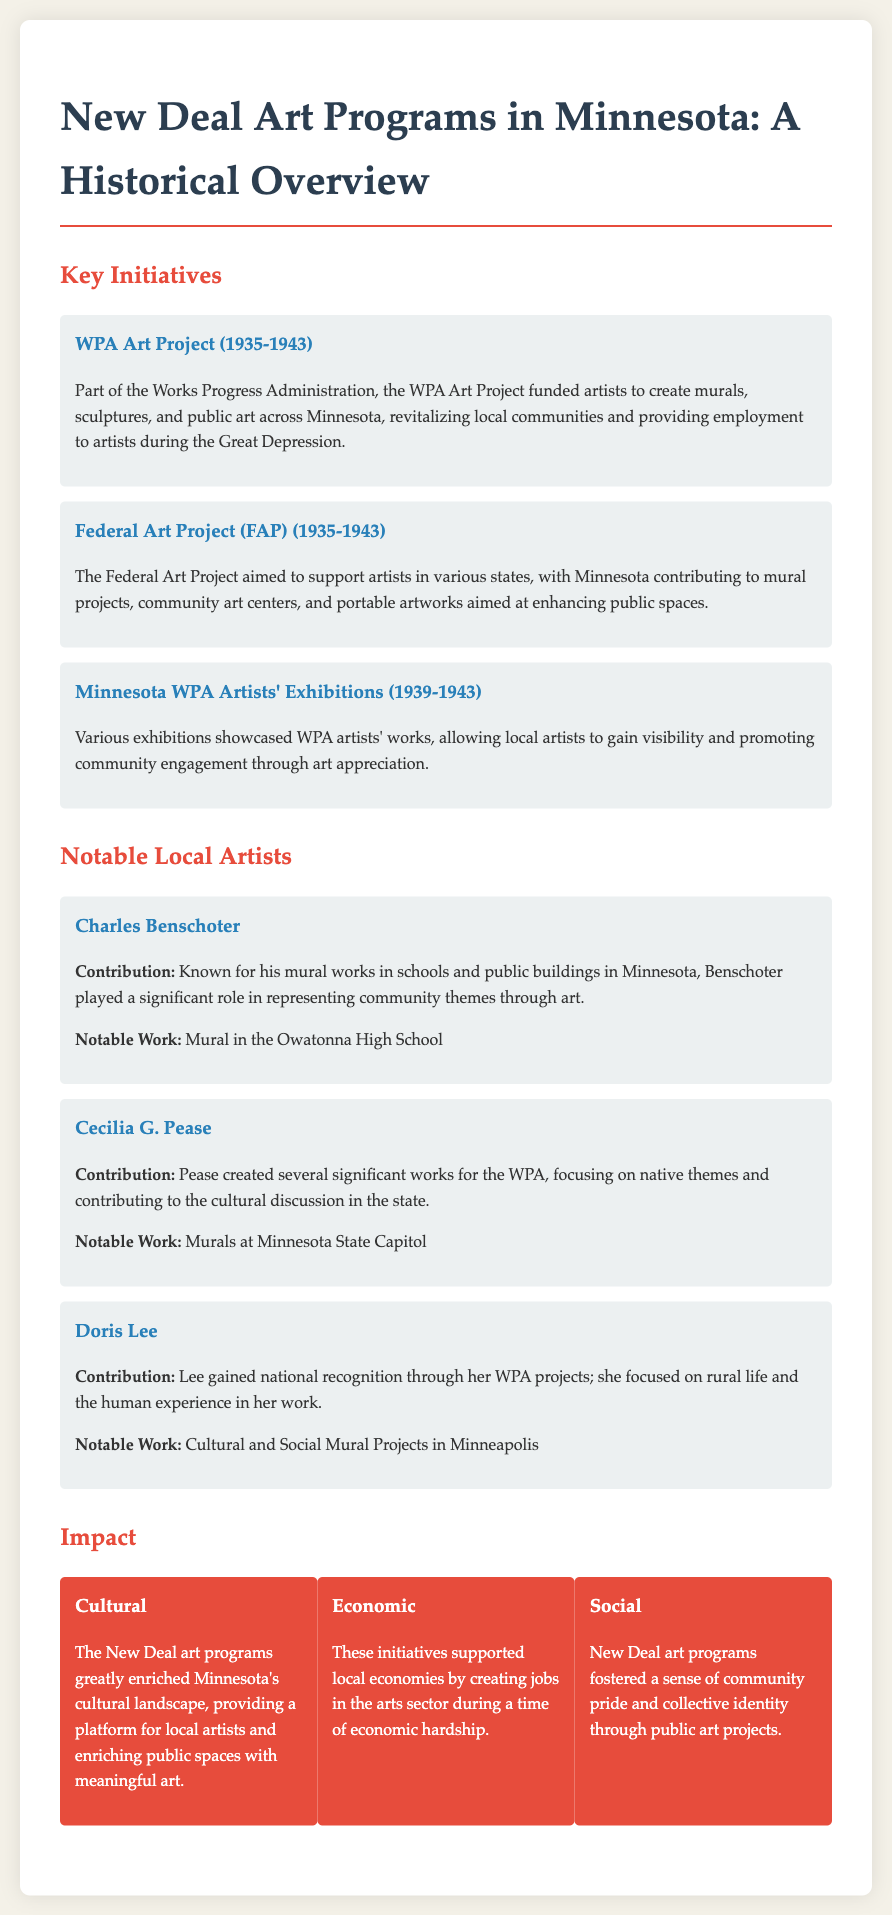What was the period of the WPA Art Project? The WPA Art Project operated from 1935 to 1943.
Answer: 1935-1943 What was one of the aims of the Federal Art Project? The Federal Art Project aimed to support artists and enhance public spaces.
Answer: Support artists Who created murals at the Minnesota State Capitol? Cecilia G. Pease is noted for creating murals at the Minnesota State Capitol.
Answer: Cecilia G. Pease What type of artwork did Doris Lee focus on? Doris Lee focused on rural life and the human experience in her art.
Answer: Rural life What initiative supported local artists through exhibitions? The Minnesota WPA Artists' Exhibitions showcased WPA artists' works.
Answer: Minnesota WPA Artists' Exhibitions What impact did New Deal art programs have on the economy? They created jobs in the arts sector during economic hardship.
Answer: Created jobs What notable work is associated with Charles Benschoter? Benschoter is known for the mural in the Owatonna High School.
Answer: Mural in the Owatonna High School How did the New Deal art programs affect local communities? They revitalized local communities by providing public art and employment.
Answer: Revitalized local communities In what artistic initiative did Minnesota artists participate? Minnesota artists participated in the Federal Art Project.
Answer: Federal Art Project 